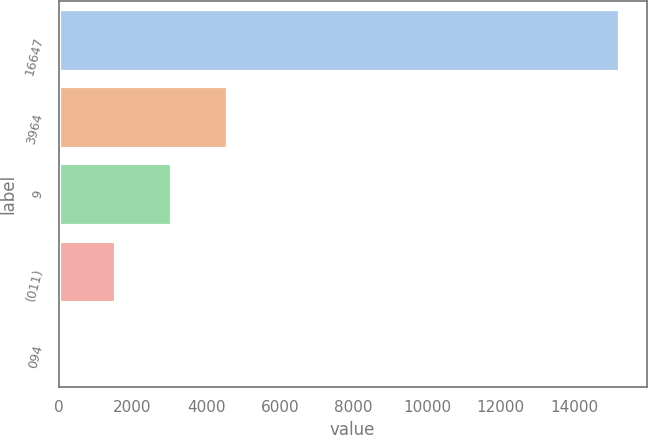<chart> <loc_0><loc_0><loc_500><loc_500><bar_chart><fcel>16647<fcel>3964<fcel>9<fcel>(011)<fcel>094<nl><fcel>15197<fcel>4559.83<fcel>3040.24<fcel>1520.65<fcel>1.06<nl></chart> 